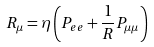Convert formula to latex. <formula><loc_0><loc_0><loc_500><loc_500>R _ { \mu } = \eta \left ( P _ { e e } + \frac { 1 } { R } P _ { \mu \mu } \right )</formula> 